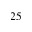Convert formula to latex. <formula><loc_0><loc_0><loc_500><loc_500>2 5</formula> 